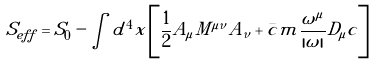Convert formula to latex. <formula><loc_0><loc_0><loc_500><loc_500>S _ { e f f } = S _ { 0 } - \int d ^ { 4 } x \left [ \frac { 1 } { 2 } A _ { \mu } M ^ { \mu \nu } A _ { \nu } + \bar { c } m \frac { \omega ^ { \mu } } { | \omega | } D _ { \mu } c \right ]</formula> 